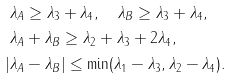Convert formula to latex. <formula><loc_0><loc_0><loc_500><loc_500>\lambda _ { A } & \geq \lambda _ { 3 } + \lambda _ { 4 } , \quad \lambda _ { B } \geq \lambda _ { 3 } + \lambda _ { 4 } , \\ \lambda _ { A } & + \lambda _ { B } \geq \lambda _ { 2 } + \lambda _ { 3 } + 2 \lambda _ { 4 } , \\ | \lambda _ { A } & - \lambda _ { B } | \leq \min ( \lambda _ { 1 } - \lambda _ { 3 } , \lambda _ { 2 } - \lambda _ { 4 } ) .</formula> 